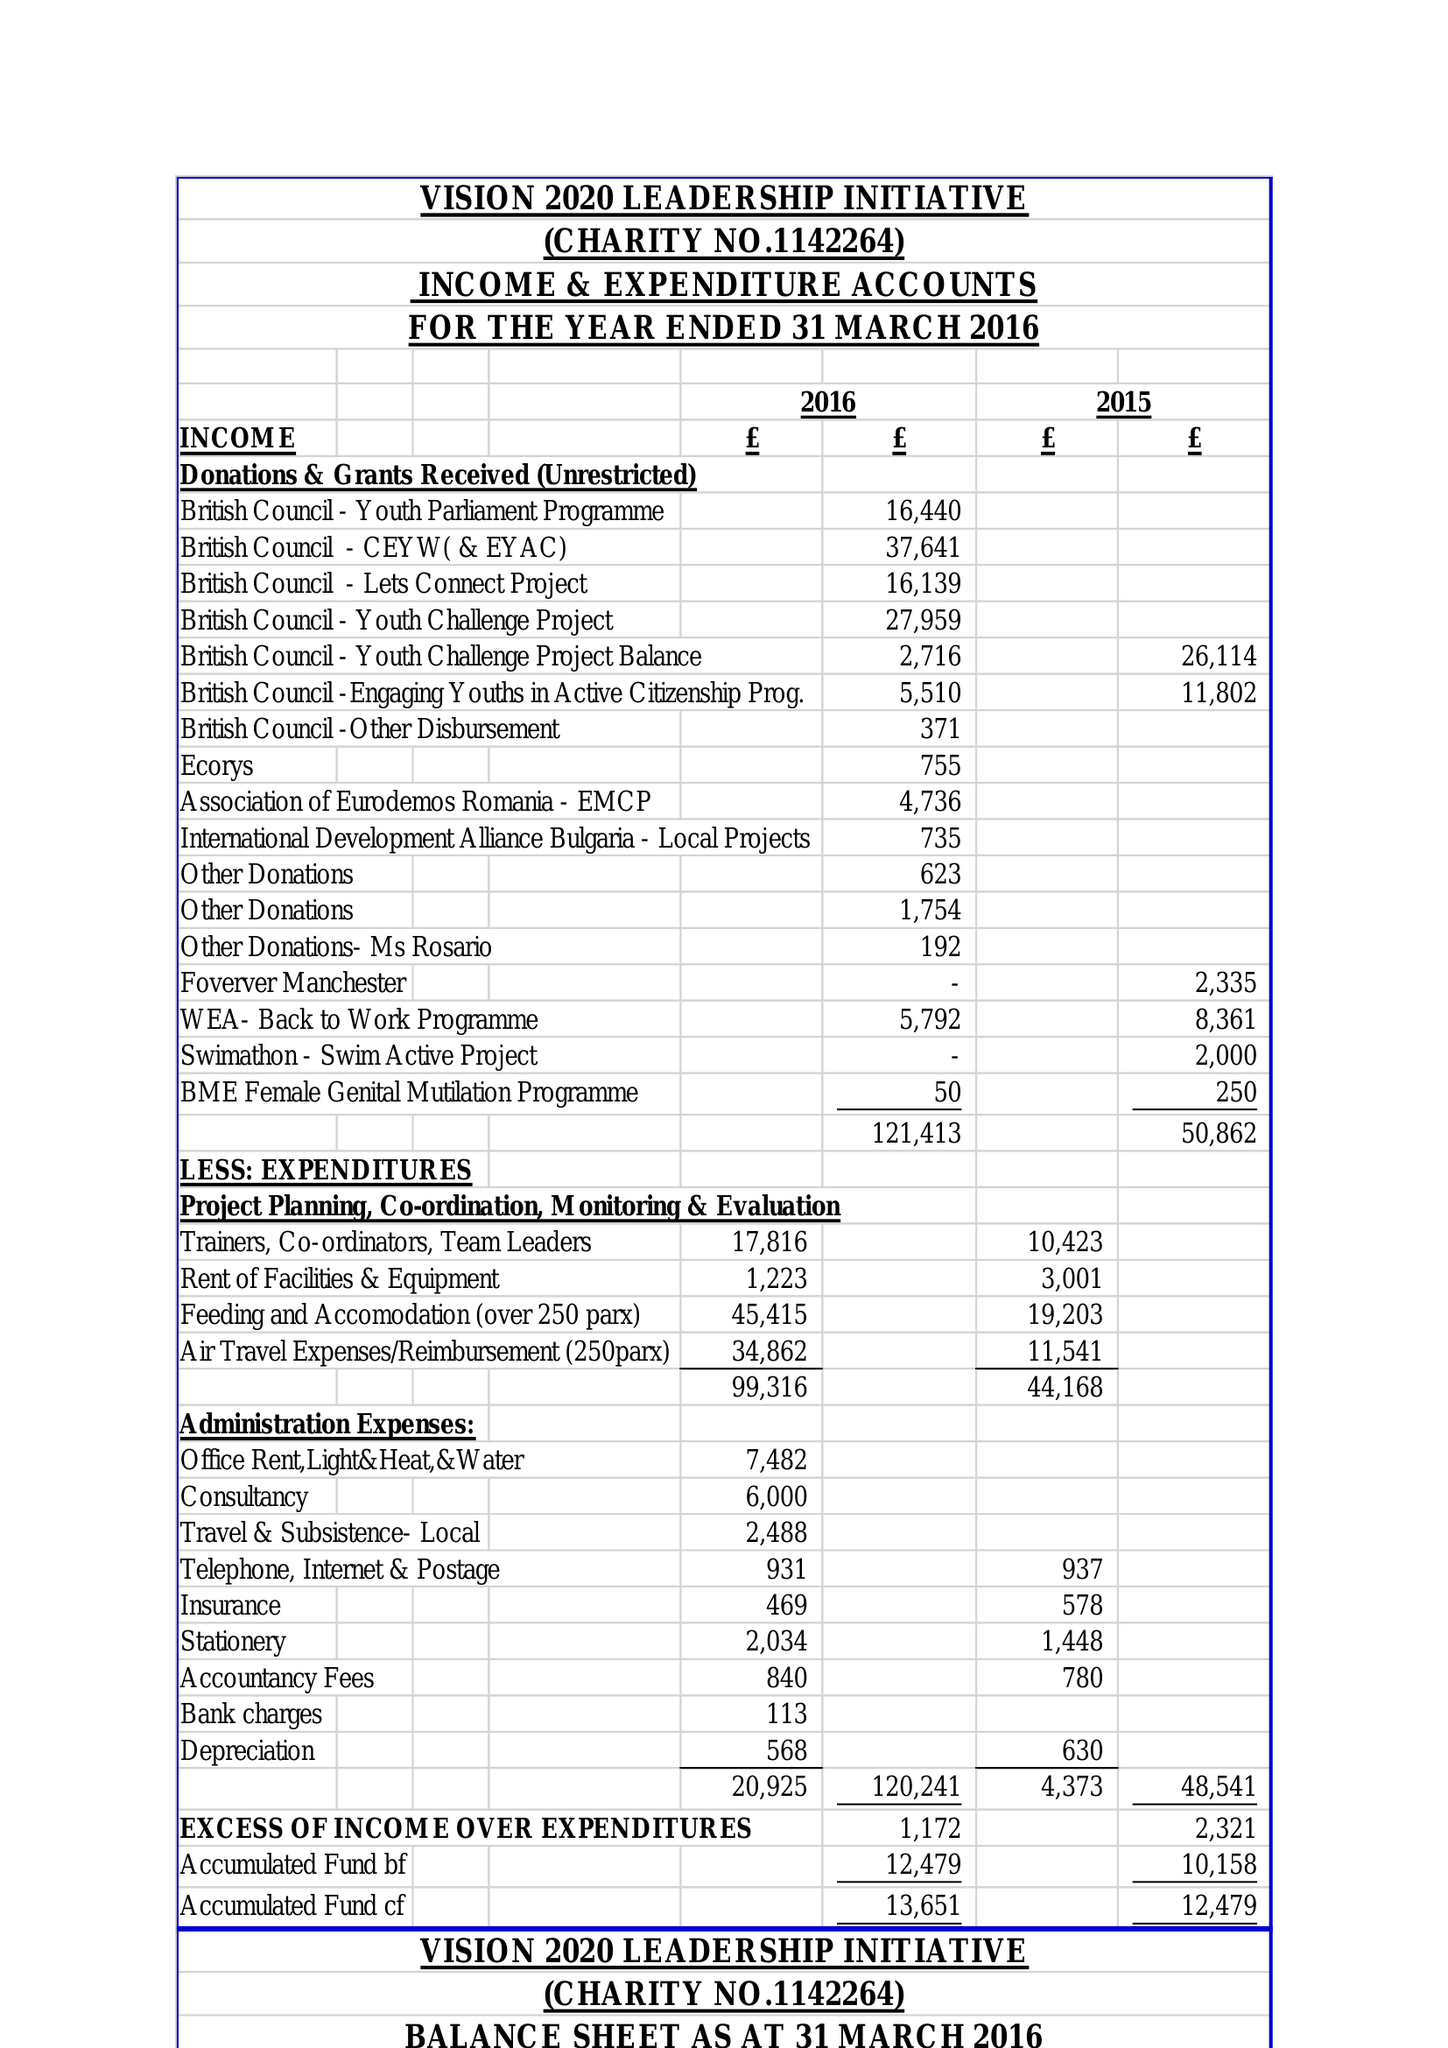What is the value for the address__postcode?
Answer the question using a single word or phrase. M18 7GD 